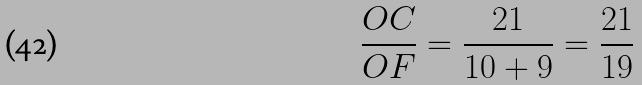<formula> <loc_0><loc_0><loc_500><loc_500>\frac { O C } { O F } = \frac { 2 1 } { 1 0 + 9 } = \frac { 2 1 } { 1 9 }</formula> 